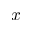<formula> <loc_0><loc_0><loc_500><loc_500>x</formula> 